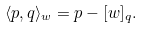<formula> <loc_0><loc_0><loc_500><loc_500>\langle p , q \rangle _ { w } = p - [ w ] _ { q } .</formula> 